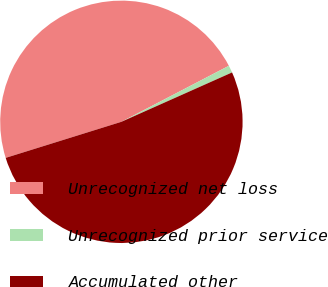Convert chart to OTSL. <chart><loc_0><loc_0><loc_500><loc_500><pie_chart><fcel>Unrecognized net loss<fcel>Unrecognized prior service<fcel>Accumulated other<nl><fcel>47.16%<fcel>0.97%<fcel>51.87%<nl></chart> 